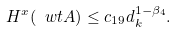Convert formula to latex. <formula><loc_0><loc_0><loc_500><loc_500>H ^ { x } ( \ w t A ) \leq c _ { 1 9 } d _ { k } ^ { 1 - \beta _ { 4 } } .</formula> 